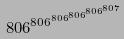Convert formula to latex. <formula><loc_0><loc_0><loc_500><loc_500>8 0 6 ^ { 8 0 6 ^ { 8 0 6 ^ { 8 0 6 ^ { 8 0 6 ^ { 8 0 7 } } } } }</formula> 